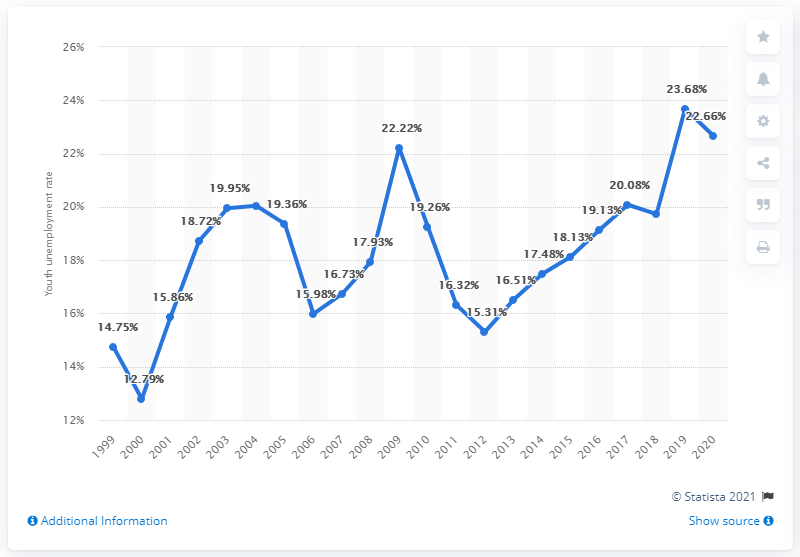List a handful of essential elements in this visual. In 2020, Turkey's youth unemployment rate was 22.66%. 